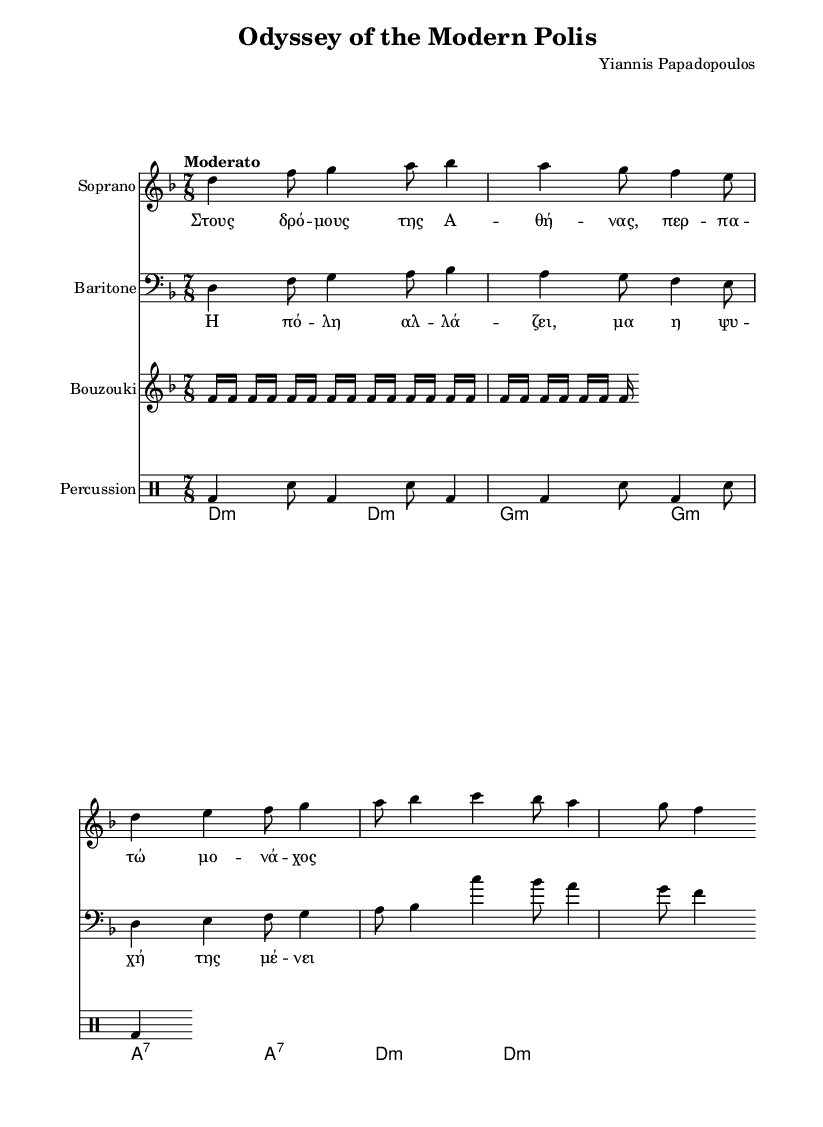What is the key signature of this music? The key is indicated by the initial part of the global settings where it states "\key d \minor", which tells us that the piece is in the key of D minor.
Answer: D minor What is the time signature of this opera piece? The time signature is found in the global settings with "\time 7/8", indicating that the piece is composed in a seven eighths time signature.
Answer: 7/8 What tempo marking is used in this score? The tempo marking is found in the global settings with "\tempo "Moderato"", which indicates the speed at which the piece should be performed.
Answer: Moderato How many lines are in the soprano staff? The treble clef for the soprano indicates the standard five-line staff used for soprano parts in music notation.
Answer: 5 What instrument provides the rhythmic foundation in this score? The percussion section, indicated by "\new DrumStaff", provides the rhythmic foundation for the piece with the written drum pattern.
Answer: Percussion What kind of chords are introduced at the beginning of the score? The chords are represented in the chord mode section with symbols such as "d2:m" and "g2:m", showing that they are minor and seventh chords at the beginning.
Answer: Minor and seventh chords What is the accompaniment instrument in this opera piece? The bouzouki, indicated by "Bouzouki", is the specific accompaniment instrument that blends traditional Greek music with this operatic composition.
Answer: Bouzouki 